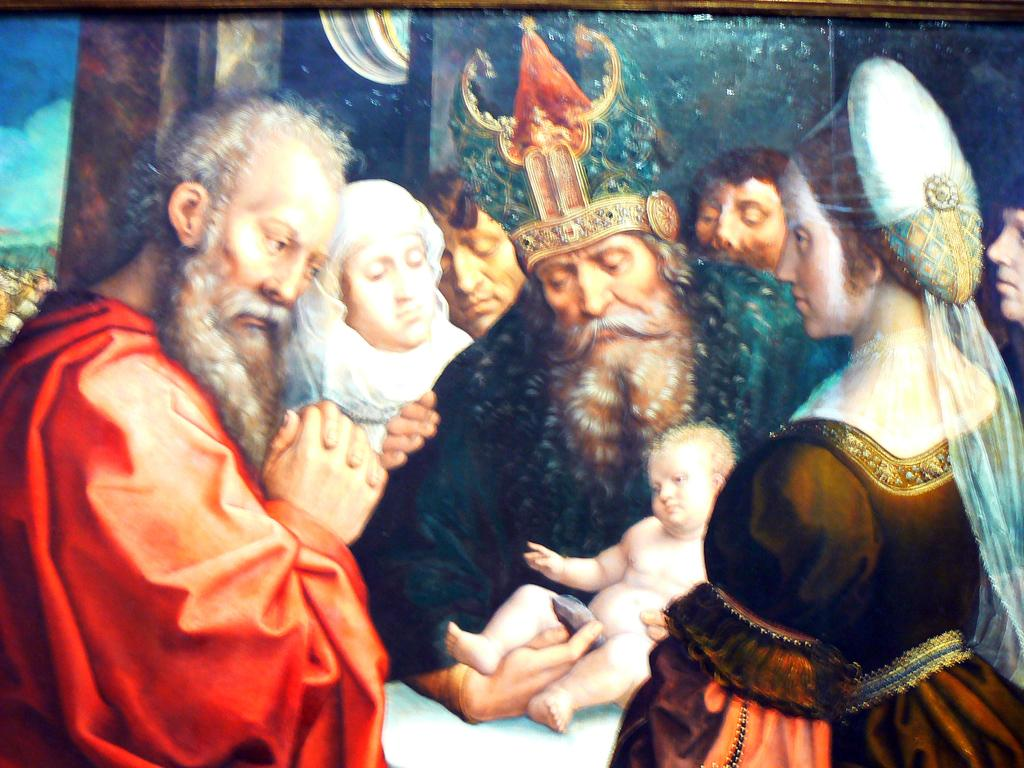What is the main subject of the image? There is a portrait in the center of the image. Can you describe the portrait? The portrait features people. How many icicles are hanging from the van in the image? There is no van or icicles present in the image; it only features a portrait with people. 